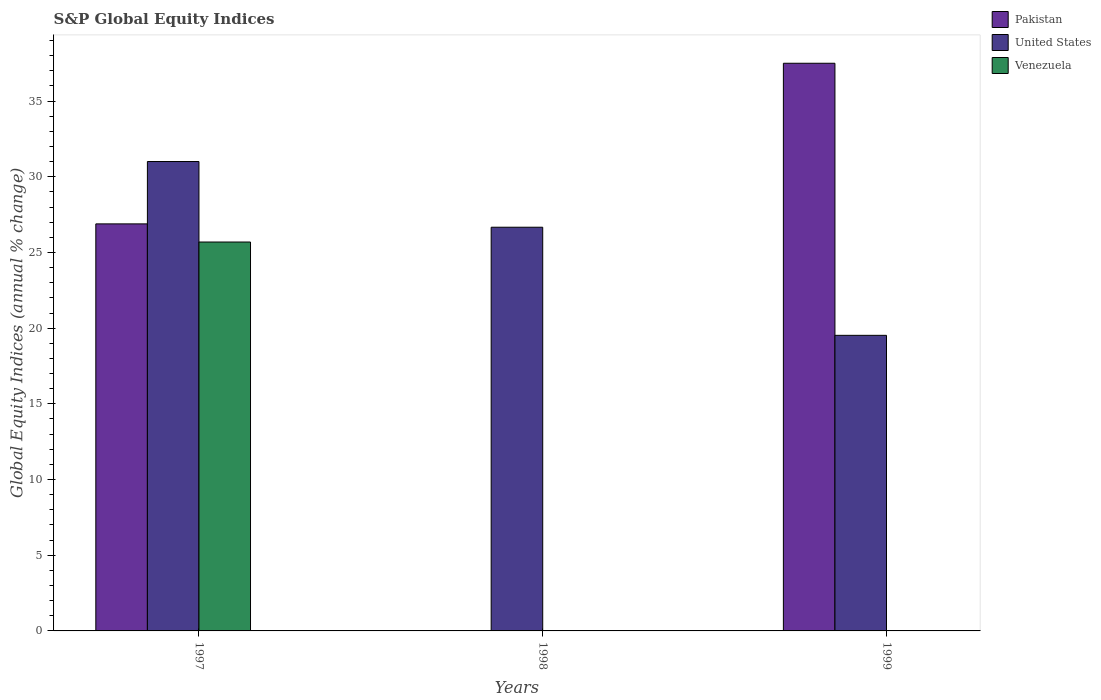How many different coloured bars are there?
Make the answer very short. 3. How many bars are there on the 2nd tick from the left?
Your response must be concise. 1. What is the label of the 1st group of bars from the left?
Provide a succinct answer. 1997. In how many cases, is the number of bars for a given year not equal to the number of legend labels?
Offer a very short reply. 2. What is the global equity indices in Pakistan in 1999?
Give a very brief answer. 37.5. Across all years, what is the maximum global equity indices in United States?
Make the answer very short. 31.01. Across all years, what is the minimum global equity indices in United States?
Your response must be concise. 19.53. What is the total global equity indices in United States in the graph?
Your answer should be compact. 77.2. What is the difference between the global equity indices in United States in 1998 and that in 1999?
Your answer should be compact. 7.14. What is the difference between the global equity indices in United States in 1997 and the global equity indices in Pakistan in 1999?
Your response must be concise. -6.49. What is the average global equity indices in Pakistan per year?
Your answer should be very brief. 21.46. In the year 1997, what is the difference between the global equity indices in Pakistan and global equity indices in Venezuela?
Keep it short and to the point. 1.2. In how many years, is the global equity indices in Pakistan greater than 35 %?
Your response must be concise. 1. What is the ratio of the global equity indices in United States in 1998 to that in 1999?
Provide a succinct answer. 1.37. Is the global equity indices in United States in 1998 less than that in 1999?
Offer a terse response. No. What is the difference between the highest and the second highest global equity indices in United States?
Ensure brevity in your answer.  4.34. What is the difference between the highest and the lowest global equity indices in United States?
Your answer should be very brief. 11.48. Is it the case that in every year, the sum of the global equity indices in Pakistan and global equity indices in Venezuela is greater than the global equity indices in United States?
Offer a very short reply. No. How many bars are there?
Provide a succinct answer. 6. Are all the bars in the graph horizontal?
Make the answer very short. No. Are the values on the major ticks of Y-axis written in scientific E-notation?
Make the answer very short. No. Does the graph contain grids?
Give a very brief answer. No. How many legend labels are there?
Your answer should be very brief. 3. What is the title of the graph?
Offer a very short reply. S&P Global Equity Indices. What is the label or title of the Y-axis?
Keep it short and to the point. Global Equity Indices (annual % change). What is the Global Equity Indices (annual % change) in Pakistan in 1997?
Ensure brevity in your answer.  26.89. What is the Global Equity Indices (annual % change) in United States in 1997?
Give a very brief answer. 31.01. What is the Global Equity Indices (annual % change) in Venezuela in 1997?
Ensure brevity in your answer.  25.69. What is the Global Equity Indices (annual % change) in Pakistan in 1998?
Make the answer very short. 0. What is the Global Equity Indices (annual % change) of United States in 1998?
Offer a terse response. 26.67. What is the Global Equity Indices (annual % change) of Venezuela in 1998?
Make the answer very short. 0. What is the Global Equity Indices (annual % change) of Pakistan in 1999?
Your answer should be very brief. 37.5. What is the Global Equity Indices (annual % change) in United States in 1999?
Keep it short and to the point. 19.53. What is the Global Equity Indices (annual % change) in Venezuela in 1999?
Provide a succinct answer. 0. Across all years, what is the maximum Global Equity Indices (annual % change) of Pakistan?
Make the answer very short. 37.5. Across all years, what is the maximum Global Equity Indices (annual % change) in United States?
Make the answer very short. 31.01. Across all years, what is the maximum Global Equity Indices (annual % change) in Venezuela?
Offer a very short reply. 25.69. Across all years, what is the minimum Global Equity Indices (annual % change) of Pakistan?
Give a very brief answer. 0. Across all years, what is the minimum Global Equity Indices (annual % change) of United States?
Ensure brevity in your answer.  19.53. What is the total Global Equity Indices (annual % change) in Pakistan in the graph?
Offer a terse response. 64.39. What is the total Global Equity Indices (annual % change) of United States in the graph?
Provide a succinct answer. 77.2. What is the total Global Equity Indices (annual % change) in Venezuela in the graph?
Your answer should be compact. 25.69. What is the difference between the Global Equity Indices (annual % change) of United States in 1997 and that in 1998?
Offer a very short reply. 4.34. What is the difference between the Global Equity Indices (annual % change) in Pakistan in 1997 and that in 1999?
Give a very brief answer. -10.61. What is the difference between the Global Equity Indices (annual % change) of United States in 1997 and that in 1999?
Provide a succinct answer. 11.48. What is the difference between the Global Equity Indices (annual % change) of United States in 1998 and that in 1999?
Provide a succinct answer. 7.14. What is the difference between the Global Equity Indices (annual % change) of Pakistan in 1997 and the Global Equity Indices (annual % change) of United States in 1998?
Make the answer very short. 0.22. What is the difference between the Global Equity Indices (annual % change) in Pakistan in 1997 and the Global Equity Indices (annual % change) in United States in 1999?
Make the answer very short. 7.36. What is the average Global Equity Indices (annual % change) in Pakistan per year?
Provide a succinct answer. 21.46. What is the average Global Equity Indices (annual % change) of United States per year?
Offer a very short reply. 25.73. What is the average Global Equity Indices (annual % change) in Venezuela per year?
Offer a very short reply. 8.56. In the year 1997, what is the difference between the Global Equity Indices (annual % change) in Pakistan and Global Equity Indices (annual % change) in United States?
Keep it short and to the point. -4.12. In the year 1997, what is the difference between the Global Equity Indices (annual % change) in Pakistan and Global Equity Indices (annual % change) in Venezuela?
Your response must be concise. 1.2. In the year 1997, what is the difference between the Global Equity Indices (annual % change) in United States and Global Equity Indices (annual % change) in Venezuela?
Provide a short and direct response. 5.32. In the year 1999, what is the difference between the Global Equity Indices (annual % change) of Pakistan and Global Equity Indices (annual % change) of United States?
Your response must be concise. 17.97. What is the ratio of the Global Equity Indices (annual % change) in United States in 1997 to that in 1998?
Keep it short and to the point. 1.16. What is the ratio of the Global Equity Indices (annual % change) of Pakistan in 1997 to that in 1999?
Ensure brevity in your answer.  0.72. What is the ratio of the Global Equity Indices (annual % change) of United States in 1997 to that in 1999?
Your answer should be compact. 1.59. What is the ratio of the Global Equity Indices (annual % change) of United States in 1998 to that in 1999?
Offer a very short reply. 1.37. What is the difference between the highest and the second highest Global Equity Indices (annual % change) in United States?
Provide a short and direct response. 4.34. What is the difference between the highest and the lowest Global Equity Indices (annual % change) in Pakistan?
Provide a short and direct response. 37.5. What is the difference between the highest and the lowest Global Equity Indices (annual % change) of United States?
Give a very brief answer. 11.48. What is the difference between the highest and the lowest Global Equity Indices (annual % change) of Venezuela?
Make the answer very short. 25.69. 